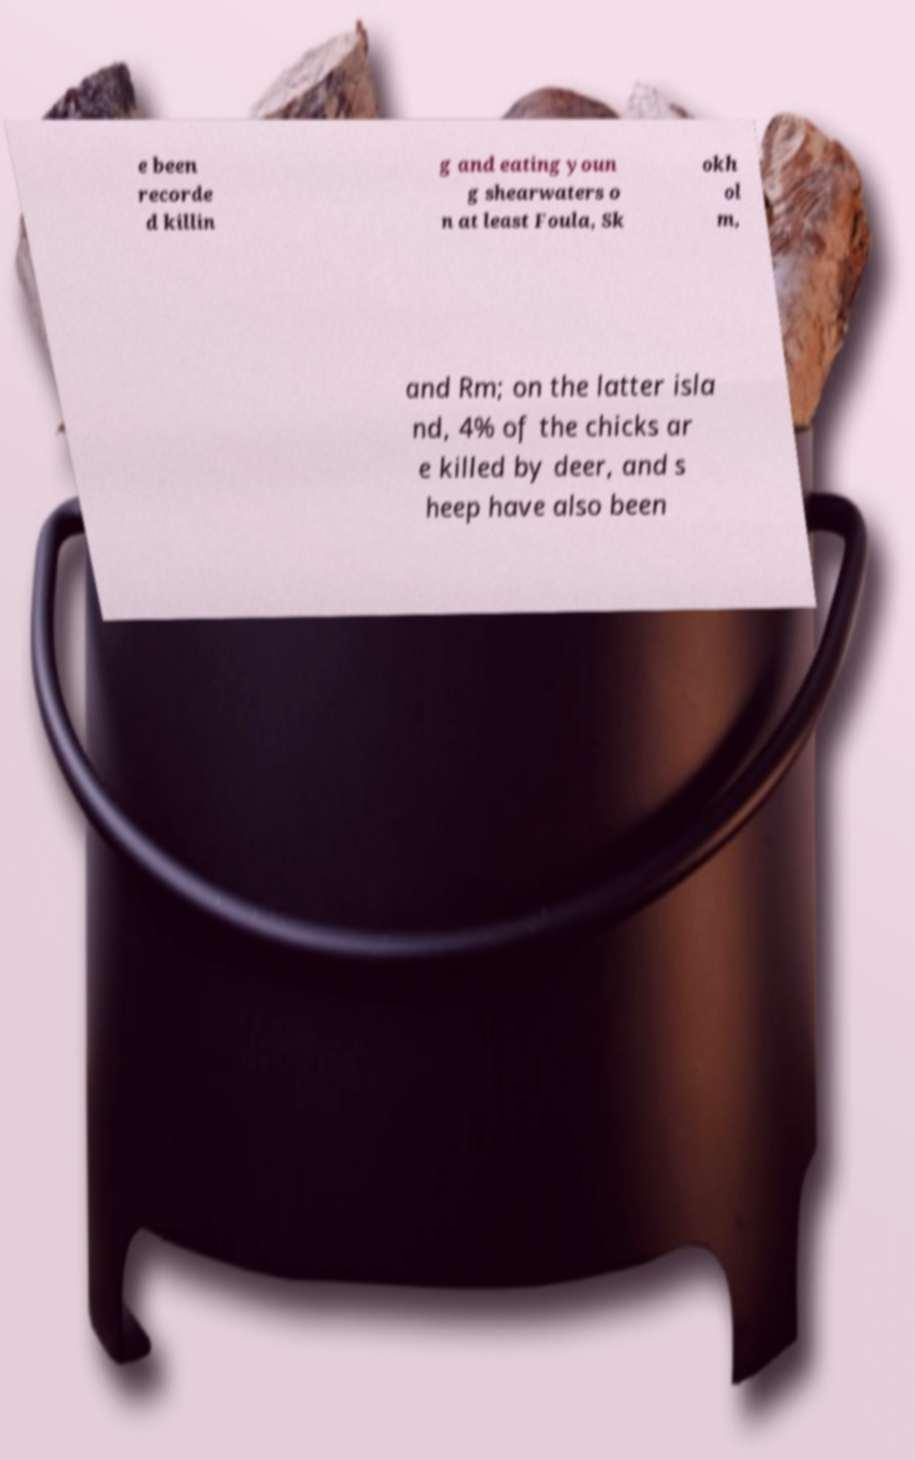Can you accurately transcribe the text from the provided image for me? e been recorde d killin g and eating youn g shearwaters o n at least Foula, Sk okh ol m, and Rm; on the latter isla nd, 4% of the chicks ar e killed by deer, and s heep have also been 